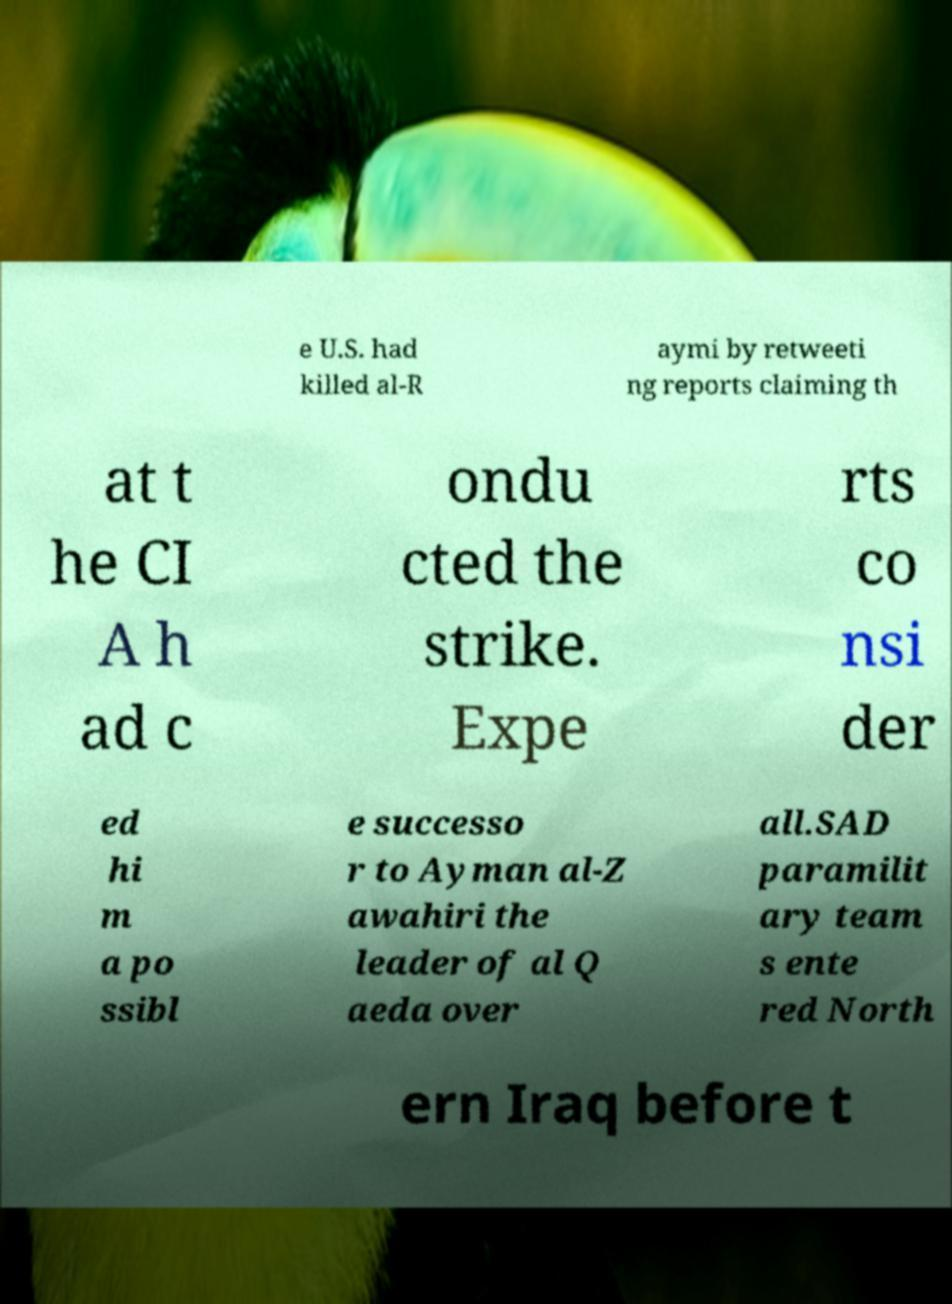What messages or text are displayed in this image? I need them in a readable, typed format. e U.S. had killed al-R aymi by retweeti ng reports claiming th at t he CI A h ad c ondu cted the strike. Expe rts co nsi der ed hi m a po ssibl e successo r to Ayman al-Z awahiri the leader of al Q aeda over all.SAD paramilit ary team s ente red North ern Iraq before t 